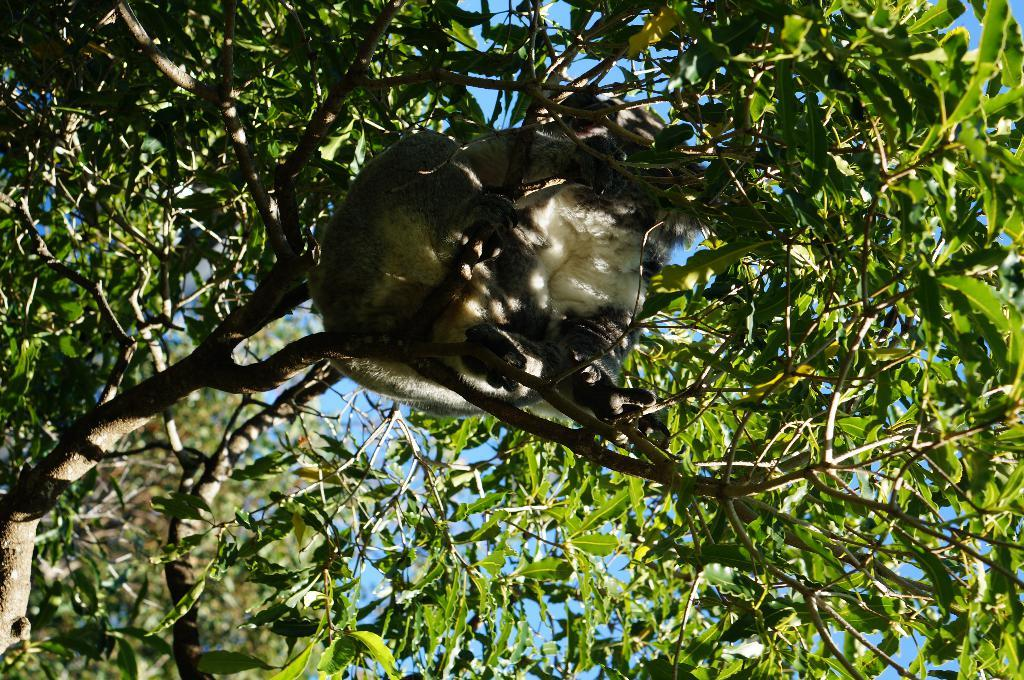What is on the tree branch in the image? There is an animal on a tree branch in the image. What can be observed about the tree in the image? The tree has green leaves. What is visible in the background of the image? The sky is visible in the background of the image. What type of cabbage is growing on the tree in the image? There is no cabbage present in the image; it features an animal on a tree branch with green leaves. Is the image taken during the winter season? The provided facts do not mention the season, so it cannot be determined from the image. 